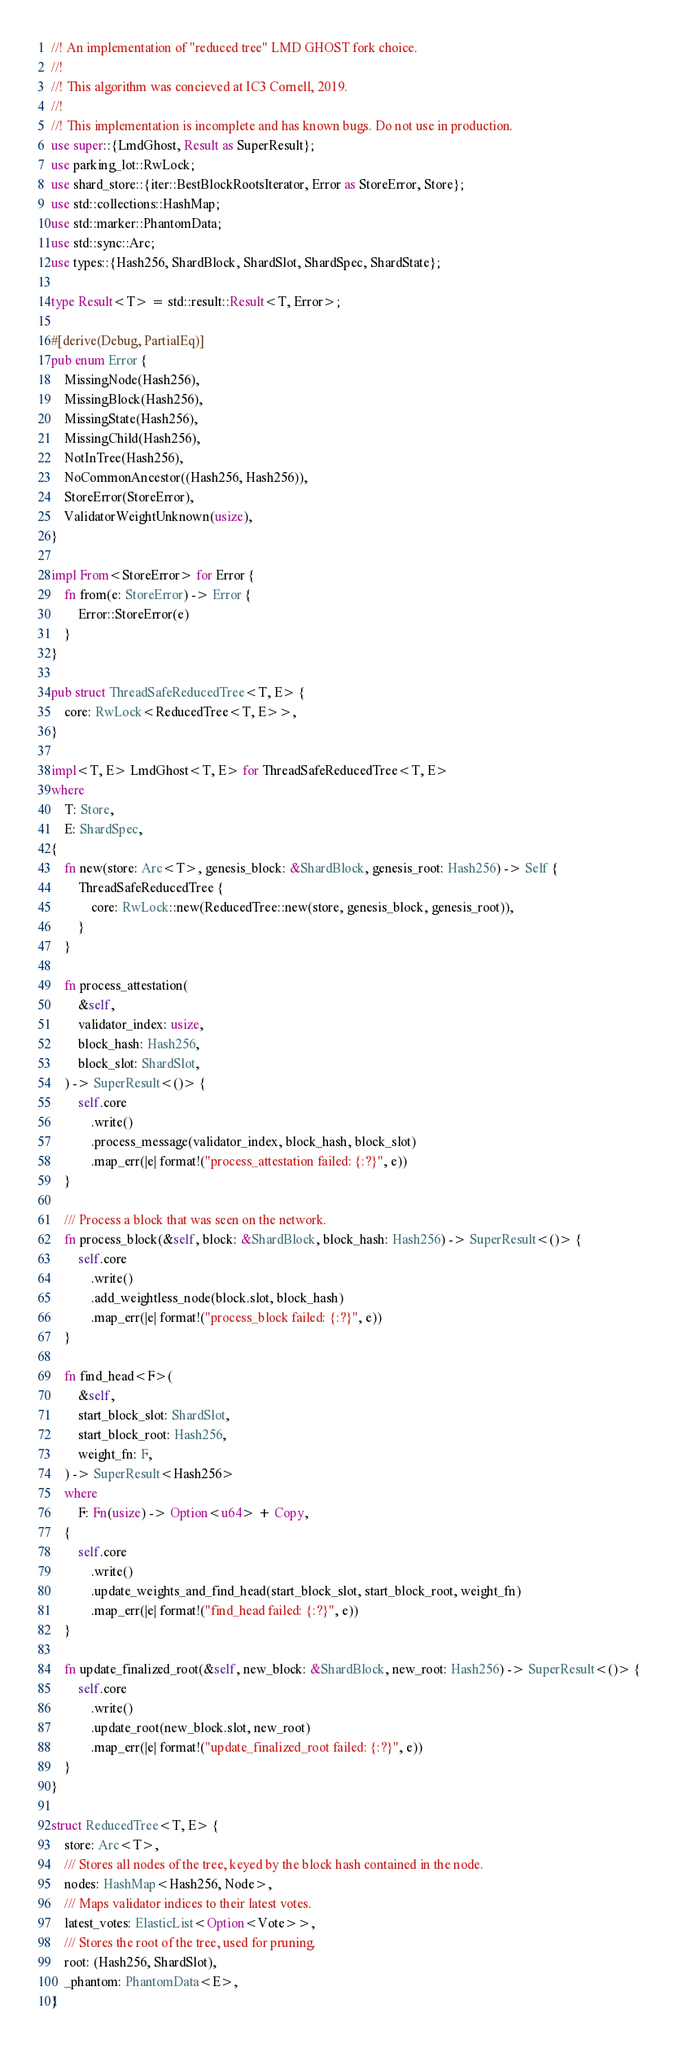Convert code to text. <code><loc_0><loc_0><loc_500><loc_500><_Rust_>//! An implementation of "reduced tree" LMD GHOST fork choice.
//!
//! This algorithm was concieved at IC3 Cornell, 2019.
//!
//! This implementation is incomplete and has known bugs. Do not use in production.
use super::{LmdGhost, Result as SuperResult};
use parking_lot::RwLock;
use shard_store::{iter::BestBlockRootsIterator, Error as StoreError, Store};
use std::collections::HashMap;
use std::marker::PhantomData;
use std::sync::Arc;
use types::{Hash256, ShardBlock, ShardSlot, ShardSpec, ShardState};

type Result<T> = std::result::Result<T, Error>;

#[derive(Debug, PartialEq)]
pub enum Error {
    MissingNode(Hash256),
    MissingBlock(Hash256),
    MissingState(Hash256),
    MissingChild(Hash256),
    NotInTree(Hash256),
    NoCommonAncestor((Hash256, Hash256)),
    StoreError(StoreError),
    ValidatorWeightUnknown(usize),
}

impl From<StoreError> for Error {
    fn from(e: StoreError) -> Error {
        Error::StoreError(e)
    }
}

pub struct ThreadSafeReducedTree<T, E> {
    core: RwLock<ReducedTree<T, E>>,
}

impl<T, E> LmdGhost<T, E> for ThreadSafeReducedTree<T, E>
where
    T: Store,
    E: ShardSpec,
{
    fn new(store: Arc<T>, genesis_block: &ShardBlock, genesis_root: Hash256) -> Self {
        ThreadSafeReducedTree {
            core: RwLock::new(ReducedTree::new(store, genesis_block, genesis_root)),
        }
    }

    fn process_attestation(
        &self,
        validator_index: usize,
        block_hash: Hash256,
        block_slot: ShardSlot,
    ) -> SuperResult<()> {
        self.core
            .write()
            .process_message(validator_index, block_hash, block_slot)
            .map_err(|e| format!("process_attestation failed: {:?}", e))
    }

    /// Process a block that was seen on the network.
    fn process_block(&self, block: &ShardBlock, block_hash: Hash256) -> SuperResult<()> {
        self.core
            .write()
            .add_weightless_node(block.slot, block_hash)
            .map_err(|e| format!("process_block failed: {:?}", e))
    }

    fn find_head<F>(
        &self,
        start_block_slot: ShardSlot,
        start_block_root: Hash256,
        weight_fn: F,
    ) -> SuperResult<Hash256>
    where
        F: Fn(usize) -> Option<u64> + Copy,
    {
        self.core
            .write()
            .update_weights_and_find_head(start_block_slot, start_block_root, weight_fn)
            .map_err(|e| format!("find_head failed: {:?}", e))
    }

    fn update_finalized_root(&self, new_block: &ShardBlock, new_root: Hash256) -> SuperResult<()> {
        self.core
            .write()
            .update_root(new_block.slot, new_root)
            .map_err(|e| format!("update_finalized_root failed: {:?}", e))
    }
}

struct ReducedTree<T, E> {
    store: Arc<T>,
    /// Stores all nodes of the tree, keyed by the block hash contained in the node.
    nodes: HashMap<Hash256, Node>,
    /// Maps validator indices to their latest votes.
    latest_votes: ElasticList<Option<Vote>>,
    /// Stores the root of the tree, used for pruning.
    root: (Hash256, ShardSlot),
    _phantom: PhantomData<E>,
}
</code> 